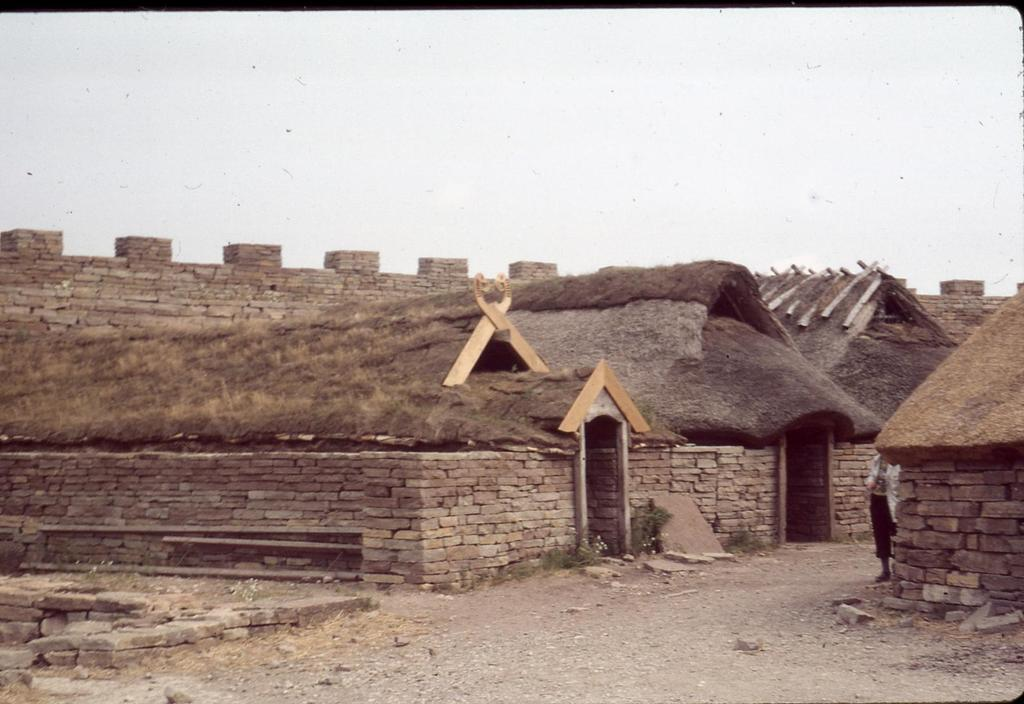What type of view is shown in the image? The image is an outside view. Can you describe the person in the image? There is a person on the road on the right side of the image. What can be seen in the background of the image? There are hurts and a wall visible in the background of the image. What is visible at the top of the image? The sky is visible at the top of the image. What type of business is being conducted in the image? There is no indication of any business being conducted in the image. What scent can be detected in the image? There is no information about any scent in the image. 